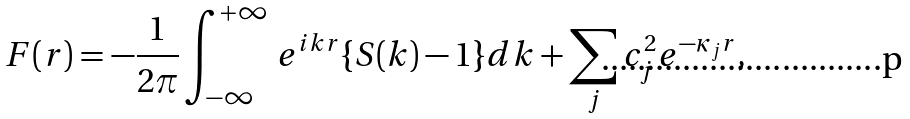<formula> <loc_0><loc_0><loc_500><loc_500>F ( r ) = - \frac { 1 } { 2 \pi } \int _ { - \infty } ^ { + \infty } \, e ^ { i k r } \{ S ( k ) - 1 \} d k + \sum _ { j } c _ { j } ^ { 2 } e ^ { - \kappa _ { j } r } ,</formula> 